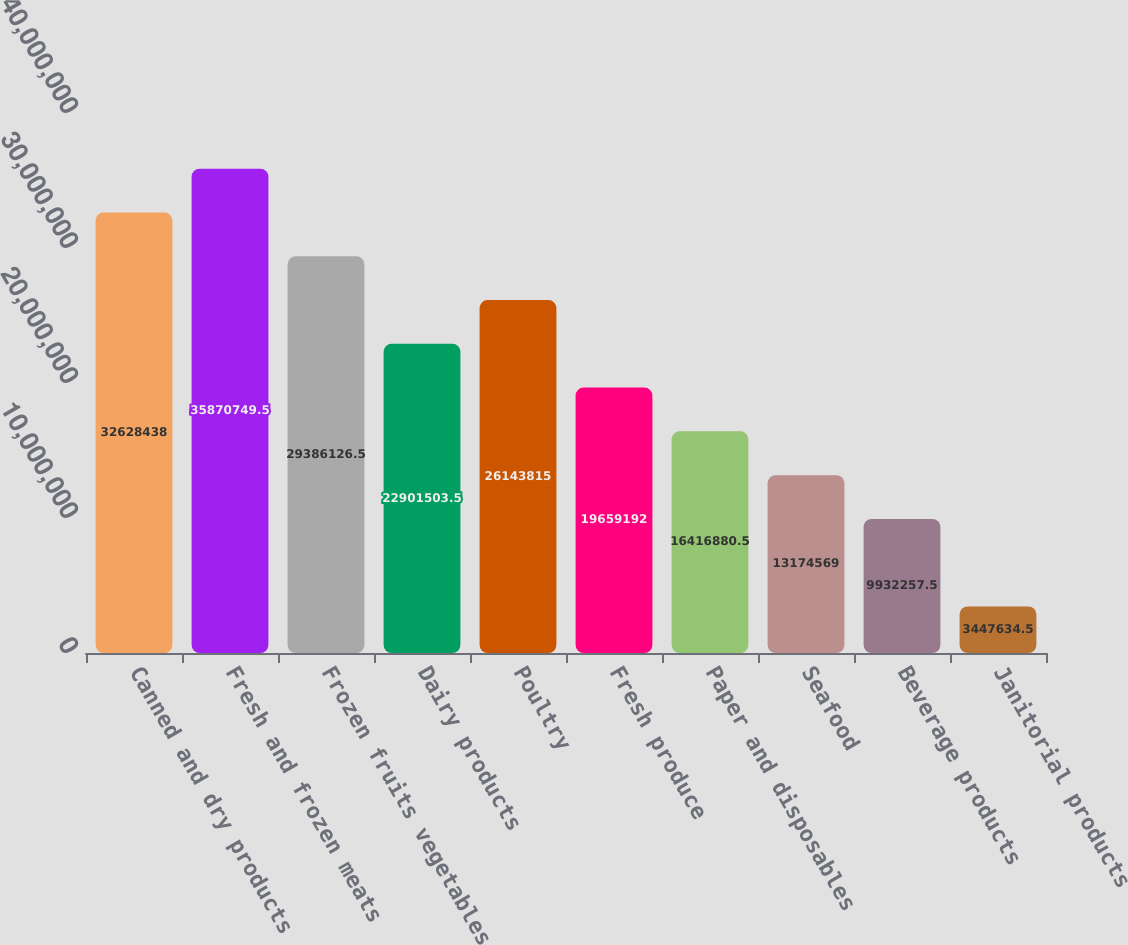Convert chart. <chart><loc_0><loc_0><loc_500><loc_500><bar_chart><fcel>Canned and dry products<fcel>Fresh and frozen meats<fcel>Frozen fruits vegetables<fcel>Dairy products<fcel>Poultry<fcel>Fresh produce<fcel>Paper and disposables<fcel>Seafood<fcel>Beverage products<fcel>Janitorial products<nl><fcel>3.26284e+07<fcel>3.58707e+07<fcel>2.93861e+07<fcel>2.29015e+07<fcel>2.61438e+07<fcel>1.96592e+07<fcel>1.64169e+07<fcel>1.31746e+07<fcel>9.93226e+06<fcel>3.44763e+06<nl></chart> 